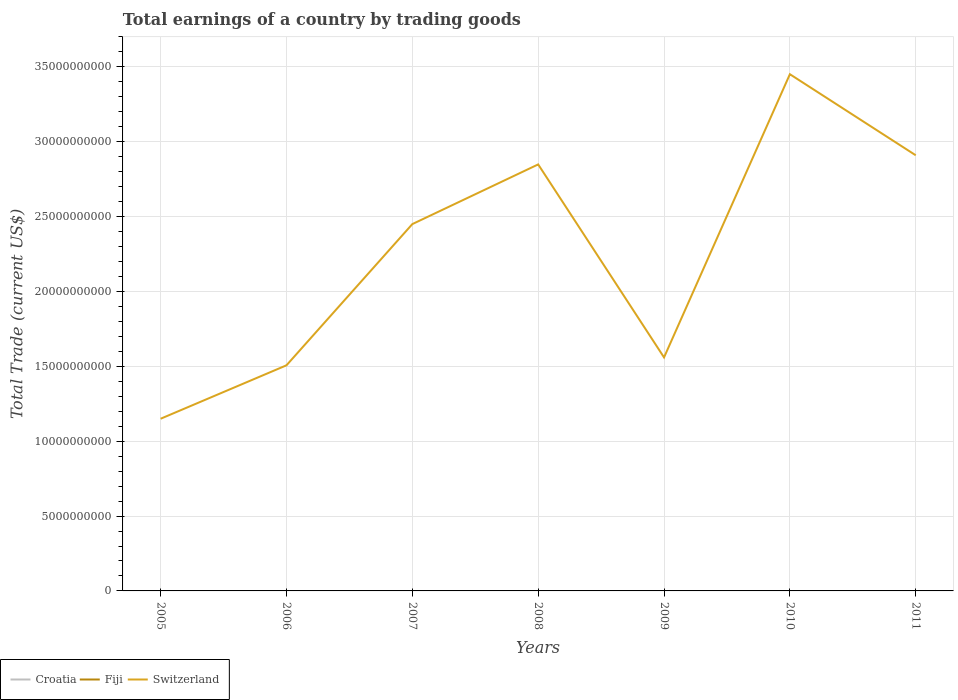How many different coloured lines are there?
Your answer should be very brief. 1. Across all years, what is the maximum total earnings in Fiji?
Ensure brevity in your answer.  0. What is the difference between the highest and the second highest total earnings in Switzerland?
Give a very brief answer. 2.30e+1. Does the graph contain any zero values?
Give a very brief answer. Yes. Does the graph contain grids?
Offer a very short reply. Yes. Where does the legend appear in the graph?
Keep it short and to the point. Bottom left. How many legend labels are there?
Ensure brevity in your answer.  3. How are the legend labels stacked?
Offer a very short reply. Horizontal. What is the title of the graph?
Keep it short and to the point. Total earnings of a country by trading goods. Does "Macao" appear as one of the legend labels in the graph?
Your answer should be compact. No. What is the label or title of the Y-axis?
Your answer should be very brief. Total Trade (current US$). What is the Total Trade (current US$) in Croatia in 2005?
Give a very brief answer. 0. What is the Total Trade (current US$) of Fiji in 2005?
Make the answer very short. 0. What is the Total Trade (current US$) of Switzerland in 2005?
Make the answer very short. 1.15e+1. What is the Total Trade (current US$) in Fiji in 2006?
Keep it short and to the point. 0. What is the Total Trade (current US$) of Switzerland in 2006?
Ensure brevity in your answer.  1.51e+1. What is the Total Trade (current US$) in Croatia in 2007?
Offer a very short reply. 0. What is the Total Trade (current US$) in Switzerland in 2007?
Provide a succinct answer. 2.45e+1. What is the Total Trade (current US$) in Fiji in 2008?
Keep it short and to the point. 0. What is the Total Trade (current US$) in Switzerland in 2008?
Offer a very short reply. 2.85e+1. What is the Total Trade (current US$) of Croatia in 2009?
Provide a short and direct response. 0. What is the Total Trade (current US$) in Switzerland in 2009?
Ensure brevity in your answer.  1.56e+1. What is the Total Trade (current US$) of Croatia in 2010?
Give a very brief answer. 0. What is the Total Trade (current US$) of Switzerland in 2010?
Offer a very short reply. 3.45e+1. What is the Total Trade (current US$) in Fiji in 2011?
Offer a very short reply. 0. What is the Total Trade (current US$) in Switzerland in 2011?
Offer a terse response. 2.91e+1. Across all years, what is the maximum Total Trade (current US$) in Switzerland?
Give a very brief answer. 3.45e+1. Across all years, what is the minimum Total Trade (current US$) of Switzerland?
Provide a succinct answer. 1.15e+1. What is the total Total Trade (current US$) of Croatia in the graph?
Offer a terse response. 0. What is the total Total Trade (current US$) of Fiji in the graph?
Provide a succinct answer. 0. What is the total Total Trade (current US$) of Switzerland in the graph?
Your response must be concise. 1.59e+11. What is the difference between the Total Trade (current US$) of Switzerland in 2005 and that in 2006?
Offer a terse response. -3.57e+09. What is the difference between the Total Trade (current US$) in Switzerland in 2005 and that in 2007?
Give a very brief answer. -1.30e+1. What is the difference between the Total Trade (current US$) of Switzerland in 2005 and that in 2008?
Your answer should be compact. -1.70e+1. What is the difference between the Total Trade (current US$) in Switzerland in 2005 and that in 2009?
Offer a terse response. -4.10e+09. What is the difference between the Total Trade (current US$) of Switzerland in 2005 and that in 2010?
Ensure brevity in your answer.  -2.30e+1. What is the difference between the Total Trade (current US$) in Switzerland in 2005 and that in 2011?
Ensure brevity in your answer.  -1.76e+1. What is the difference between the Total Trade (current US$) of Switzerland in 2006 and that in 2007?
Your answer should be compact. -9.43e+09. What is the difference between the Total Trade (current US$) in Switzerland in 2006 and that in 2008?
Offer a terse response. -1.34e+1. What is the difference between the Total Trade (current US$) of Switzerland in 2006 and that in 2009?
Ensure brevity in your answer.  -5.28e+08. What is the difference between the Total Trade (current US$) of Switzerland in 2006 and that in 2010?
Ensure brevity in your answer.  -1.94e+1. What is the difference between the Total Trade (current US$) in Switzerland in 2006 and that in 2011?
Your answer should be very brief. -1.40e+1. What is the difference between the Total Trade (current US$) in Switzerland in 2007 and that in 2008?
Your response must be concise. -3.99e+09. What is the difference between the Total Trade (current US$) of Switzerland in 2007 and that in 2009?
Keep it short and to the point. 8.90e+09. What is the difference between the Total Trade (current US$) in Switzerland in 2007 and that in 2010?
Offer a very short reply. -1.00e+1. What is the difference between the Total Trade (current US$) in Switzerland in 2007 and that in 2011?
Ensure brevity in your answer.  -4.60e+09. What is the difference between the Total Trade (current US$) in Switzerland in 2008 and that in 2009?
Offer a terse response. 1.29e+1. What is the difference between the Total Trade (current US$) of Switzerland in 2008 and that in 2010?
Your answer should be compact. -6.02e+09. What is the difference between the Total Trade (current US$) in Switzerland in 2008 and that in 2011?
Give a very brief answer. -6.10e+08. What is the difference between the Total Trade (current US$) in Switzerland in 2009 and that in 2010?
Ensure brevity in your answer.  -1.89e+1. What is the difference between the Total Trade (current US$) in Switzerland in 2009 and that in 2011?
Keep it short and to the point. -1.35e+1. What is the difference between the Total Trade (current US$) of Switzerland in 2010 and that in 2011?
Offer a terse response. 5.41e+09. What is the average Total Trade (current US$) in Croatia per year?
Give a very brief answer. 0. What is the average Total Trade (current US$) in Switzerland per year?
Offer a very short reply. 2.27e+1. What is the ratio of the Total Trade (current US$) of Switzerland in 2005 to that in 2006?
Make the answer very short. 0.76. What is the ratio of the Total Trade (current US$) of Switzerland in 2005 to that in 2007?
Provide a short and direct response. 0.47. What is the ratio of the Total Trade (current US$) in Switzerland in 2005 to that in 2008?
Make the answer very short. 0.4. What is the ratio of the Total Trade (current US$) of Switzerland in 2005 to that in 2009?
Make the answer very short. 0.74. What is the ratio of the Total Trade (current US$) of Switzerland in 2005 to that in 2010?
Your answer should be compact. 0.33. What is the ratio of the Total Trade (current US$) of Switzerland in 2005 to that in 2011?
Give a very brief answer. 0.4. What is the ratio of the Total Trade (current US$) of Switzerland in 2006 to that in 2007?
Your answer should be very brief. 0.61. What is the ratio of the Total Trade (current US$) of Switzerland in 2006 to that in 2008?
Provide a short and direct response. 0.53. What is the ratio of the Total Trade (current US$) in Switzerland in 2006 to that in 2009?
Your answer should be compact. 0.97. What is the ratio of the Total Trade (current US$) of Switzerland in 2006 to that in 2010?
Keep it short and to the point. 0.44. What is the ratio of the Total Trade (current US$) of Switzerland in 2006 to that in 2011?
Give a very brief answer. 0.52. What is the ratio of the Total Trade (current US$) in Switzerland in 2007 to that in 2008?
Your response must be concise. 0.86. What is the ratio of the Total Trade (current US$) in Switzerland in 2007 to that in 2009?
Give a very brief answer. 1.57. What is the ratio of the Total Trade (current US$) of Switzerland in 2007 to that in 2010?
Keep it short and to the point. 0.71. What is the ratio of the Total Trade (current US$) of Switzerland in 2007 to that in 2011?
Ensure brevity in your answer.  0.84. What is the ratio of the Total Trade (current US$) in Switzerland in 2008 to that in 2009?
Offer a terse response. 1.83. What is the ratio of the Total Trade (current US$) of Switzerland in 2008 to that in 2010?
Your response must be concise. 0.83. What is the ratio of the Total Trade (current US$) in Switzerland in 2009 to that in 2010?
Your response must be concise. 0.45. What is the ratio of the Total Trade (current US$) of Switzerland in 2009 to that in 2011?
Provide a short and direct response. 0.54. What is the ratio of the Total Trade (current US$) of Switzerland in 2010 to that in 2011?
Give a very brief answer. 1.19. What is the difference between the highest and the second highest Total Trade (current US$) of Switzerland?
Your answer should be compact. 5.41e+09. What is the difference between the highest and the lowest Total Trade (current US$) of Switzerland?
Make the answer very short. 2.30e+1. 